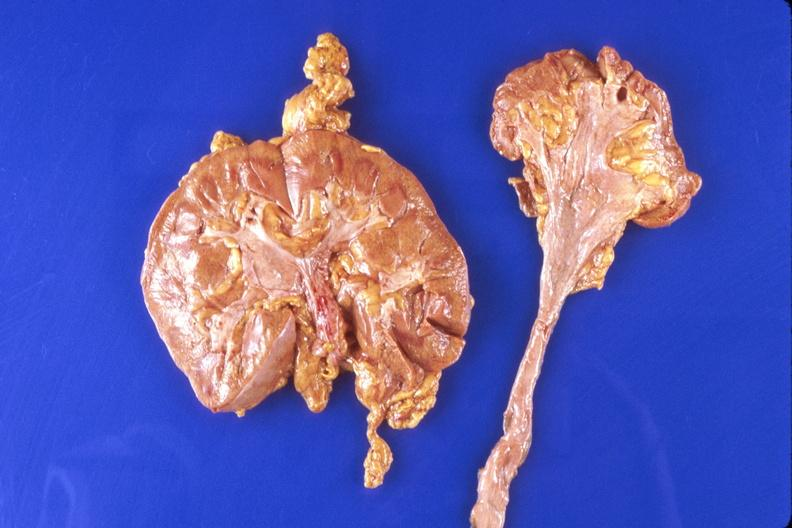where is this?
Answer the question using a single word or phrase. Urinary 